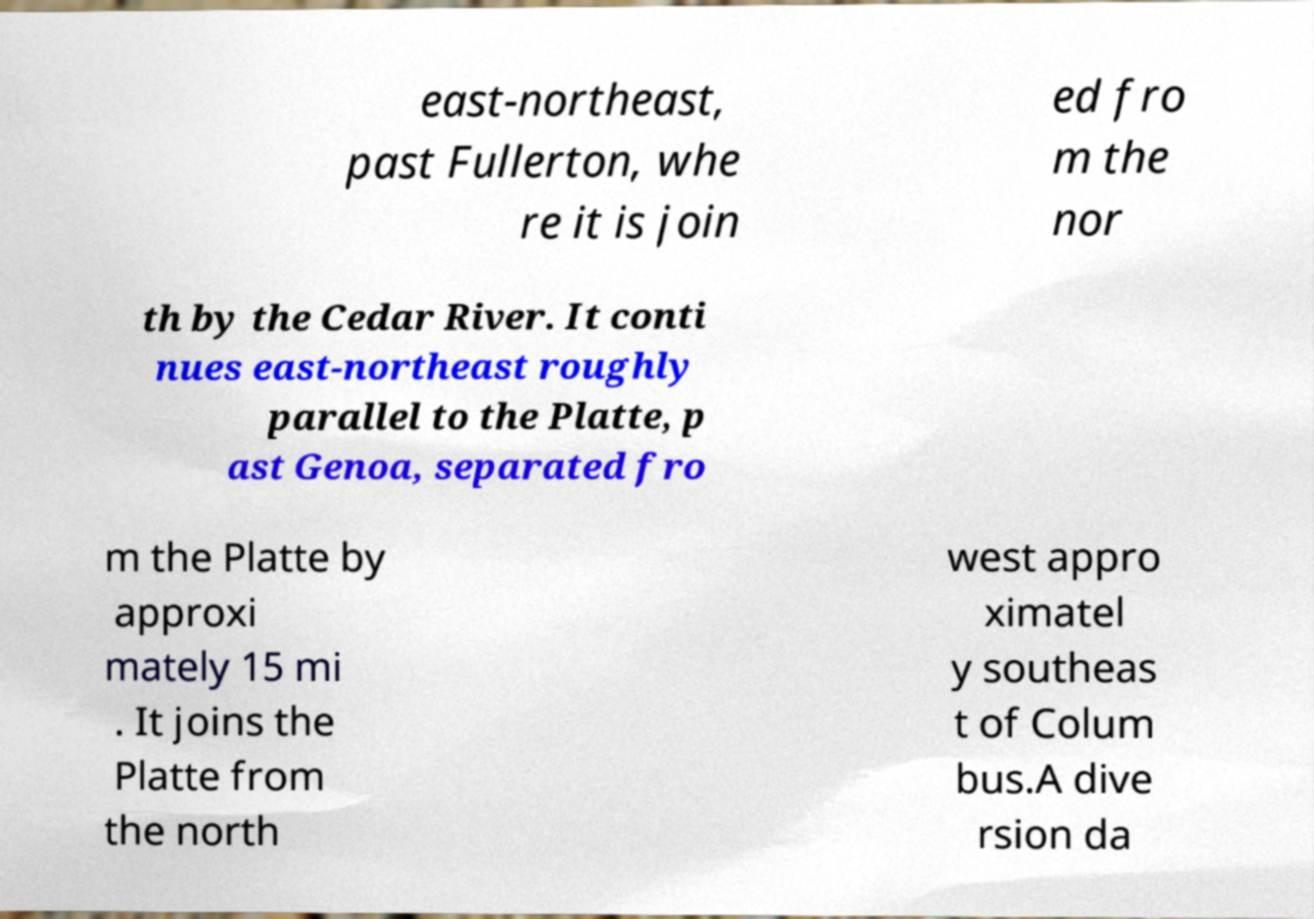Can you accurately transcribe the text from the provided image for me? east-northeast, past Fullerton, whe re it is join ed fro m the nor th by the Cedar River. It conti nues east-northeast roughly parallel to the Platte, p ast Genoa, separated fro m the Platte by approxi mately 15 mi . It joins the Platte from the north west appro ximatel y southeas t of Colum bus.A dive rsion da 